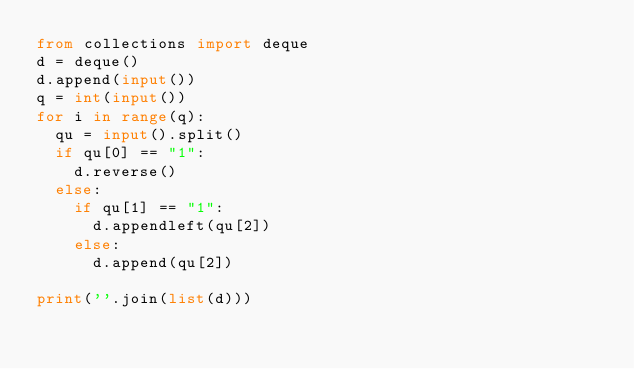Convert code to text. <code><loc_0><loc_0><loc_500><loc_500><_Python_>from collections import deque
d = deque()
d.append(input())
q = int(input())
for i in range(q):
  qu = input().split()
  if qu[0] == "1":
    d.reverse()
  else:
    if qu[1] == "1":
      d.appendleft(qu[2])
    else:
      d.append(qu[2])

print(''.join(list(d)))</code> 